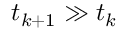Convert formula to latex. <formula><loc_0><loc_0><loc_500><loc_500>t _ { k + 1 } \gg t _ { k }</formula> 